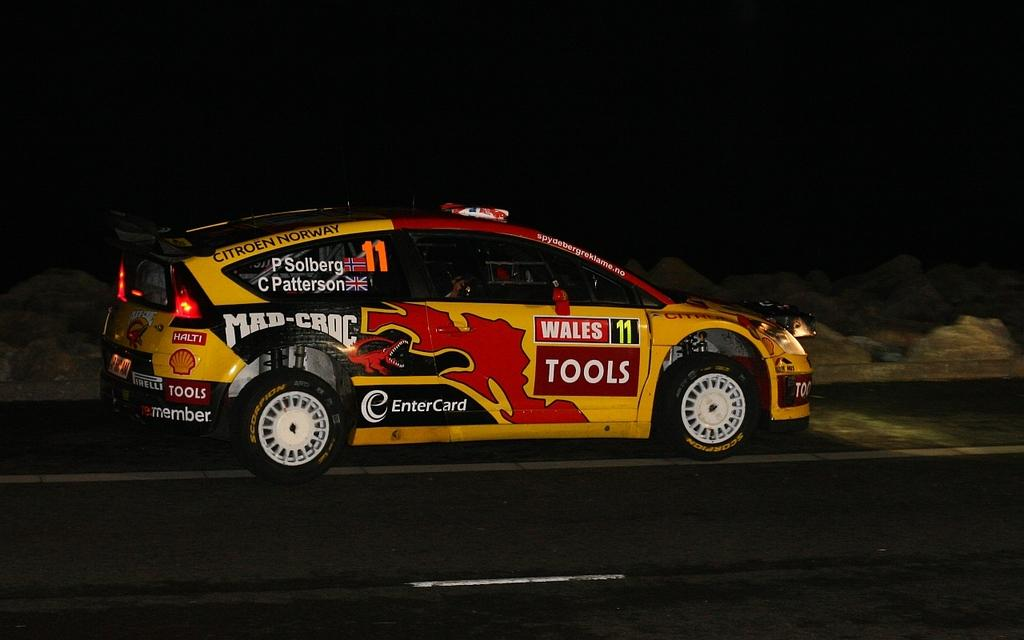What type of vehicle is in the image? There is a vehicle with wheels in the image. Where is the vehicle located? The vehicle is on the road. What can be observed about the background of the image? The background of the image is dark. What type of crayon is being used to draw on the bushes in the image? There is no crayon or bushes present in the image. 